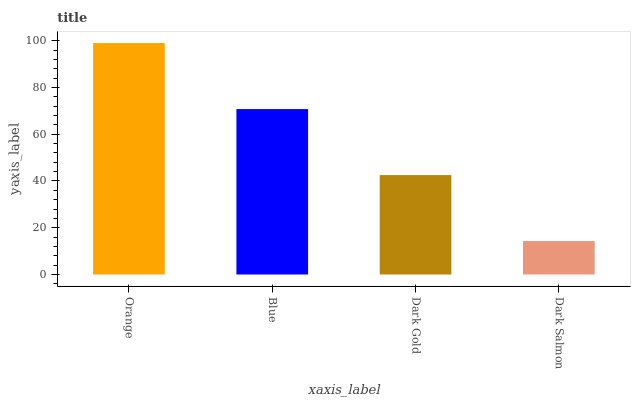Is Dark Salmon the minimum?
Answer yes or no. Yes. Is Orange the maximum?
Answer yes or no. Yes. Is Blue the minimum?
Answer yes or no. No. Is Blue the maximum?
Answer yes or no. No. Is Orange greater than Blue?
Answer yes or no. Yes. Is Blue less than Orange?
Answer yes or no. Yes. Is Blue greater than Orange?
Answer yes or no. No. Is Orange less than Blue?
Answer yes or no. No. Is Blue the high median?
Answer yes or no. Yes. Is Dark Gold the low median?
Answer yes or no. Yes. Is Dark Gold the high median?
Answer yes or no. No. Is Orange the low median?
Answer yes or no. No. 